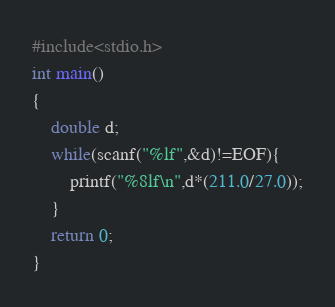<code> <loc_0><loc_0><loc_500><loc_500><_C_>#include<stdio.h>
int main()
{
	double d;
	while(scanf("%lf",&d)!=EOF){
		printf("%8lf\n",d*(211.0/27.0));
	}
	return 0;
}</code> 